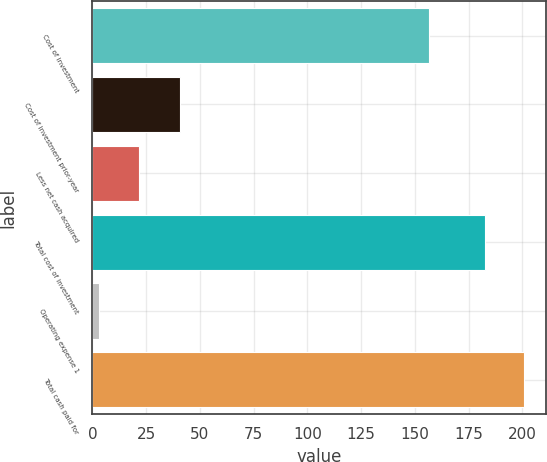Convert chart to OTSL. <chart><loc_0><loc_0><loc_500><loc_500><bar_chart><fcel>Cost of investment<fcel>Cost of investment prior-year<fcel>Less net cash acquired<fcel>Total cost of investment<fcel>Operating expense 1<fcel>Total cash paid for<nl><fcel>156.8<fcel>40.6<fcel>21.46<fcel>182.6<fcel>3.2<fcel>200.86<nl></chart> 